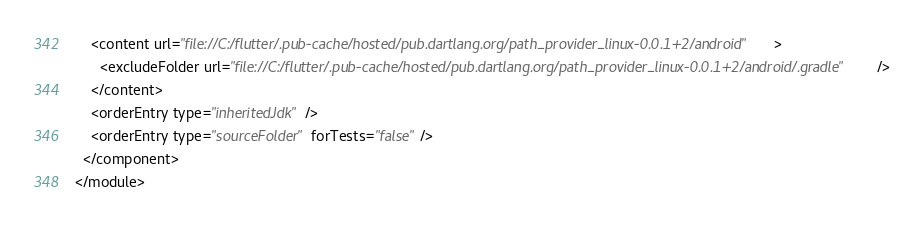<code> <loc_0><loc_0><loc_500><loc_500><_XML_>    <content url="file://C:/flutter/.pub-cache/hosted/pub.dartlang.org/path_provider_linux-0.0.1+2/android">
      <excludeFolder url="file://C:/flutter/.pub-cache/hosted/pub.dartlang.org/path_provider_linux-0.0.1+2/android/.gradle" />
    </content>
    <orderEntry type="inheritedJdk" />
    <orderEntry type="sourceFolder" forTests="false" />
  </component>
</module></code> 